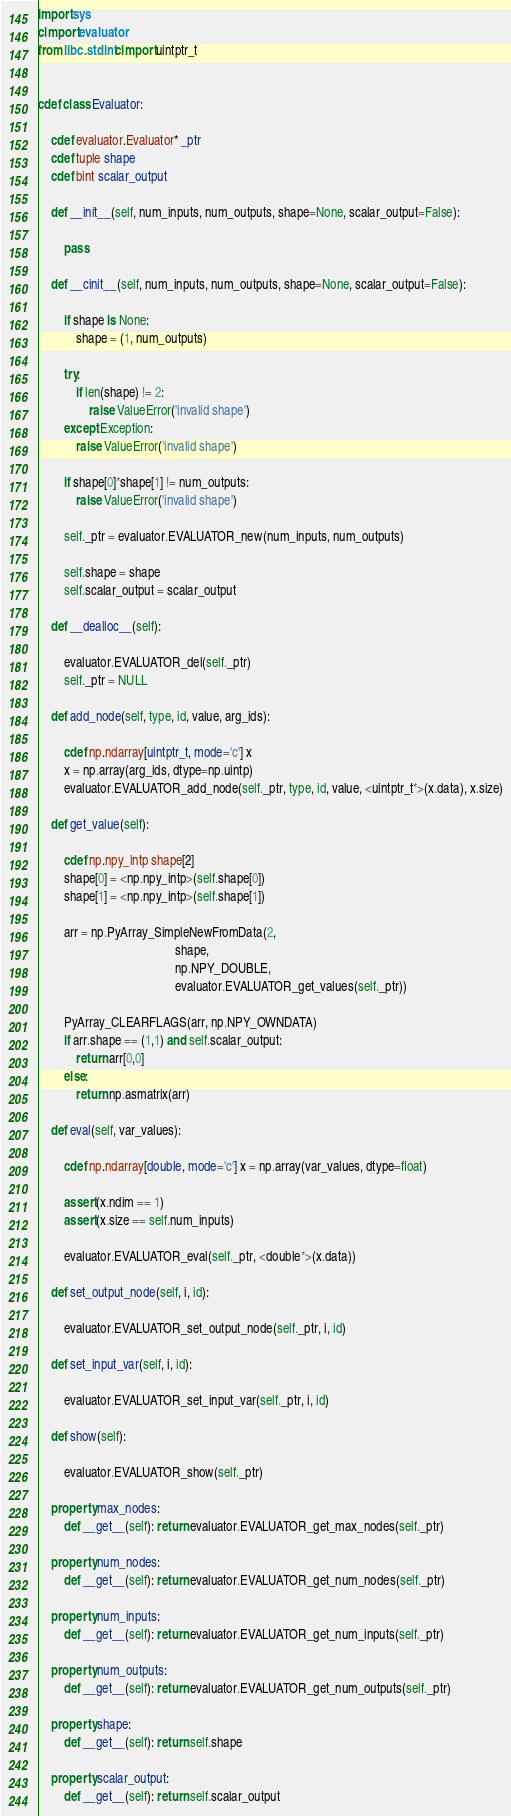Convert code to text. <code><loc_0><loc_0><loc_500><loc_500><_Cython_>import sys
cimport evaluator
from libc.stdint cimport uintptr_t


cdef class Evaluator:

    cdef evaluator.Evaluator* _ptr
    cdef tuple shape
    cdef bint scalar_output

    def __init__(self, num_inputs, num_outputs, shape=None, scalar_output=False):

        pass

    def __cinit__(self, num_inputs, num_outputs, shape=None, scalar_output=False):

        if shape is None:
            shape = (1, num_outputs)

        try:
            if len(shape) != 2:
                raise ValueError('invalid shape')
        except Exception:
            raise ValueError('invalid shape')

        if shape[0]*shape[1] != num_outputs:
            raise ValueError('invalid shape')

        self._ptr = evaluator.EVALUATOR_new(num_inputs, num_outputs)

        self.shape = shape
        self.scalar_output = scalar_output

    def __dealloc__(self):

        evaluator.EVALUATOR_del(self._ptr)
        self._ptr = NULL

    def add_node(self, type, id, value, arg_ids):

        cdef np.ndarray[uintptr_t, mode='c'] x
        x = np.array(arg_ids, dtype=np.uintp)
        evaluator.EVALUATOR_add_node(self._ptr, type, id, value, <uintptr_t*>(x.data), x.size)

    def get_value(self):

        cdef np.npy_intp shape[2]
        shape[0] = <np.npy_intp>(self.shape[0])
        shape[1] = <np.npy_intp>(self.shape[1])

        arr = np.PyArray_SimpleNewFromData(2,
                                           shape,
                                           np.NPY_DOUBLE,
                                           evaluator.EVALUATOR_get_values(self._ptr))

        PyArray_CLEARFLAGS(arr, np.NPY_OWNDATA)
        if arr.shape == (1,1) and self.scalar_output:
            return arr[0,0]
        else:
            return np.asmatrix(arr)

    def eval(self, var_values):

        cdef np.ndarray[double, mode='c'] x = np.array(var_values, dtype=float)

        assert(x.ndim == 1)
        assert(x.size == self.num_inputs)

        evaluator.EVALUATOR_eval(self._ptr, <double*>(x.data))

    def set_output_node(self, i, id):

        evaluator.EVALUATOR_set_output_node(self._ptr, i, id)

    def set_input_var(self, i, id):

        evaluator.EVALUATOR_set_input_var(self._ptr, i, id)

    def show(self):

        evaluator.EVALUATOR_show(self._ptr)

    property max_nodes:
        def __get__(self): return evaluator.EVALUATOR_get_max_nodes(self._ptr)

    property num_nodes:
        def __get__(self): return evaluator.EVALUATOR_get_num_nodes(self._ptr)

    property num_inputs:
        def __get__(self): return evaluator.EVALUATOR_get_num_inputs(self._ptr)

    property num_outputs:
        def __get__(self): return evaluator.EVALUATOR_get_num_outputs(self._ptr)

    property shape:
        def __get__(self): return self.shape

    property scalar_output:
        def __get__(self): return self.scalar_output
</code> 